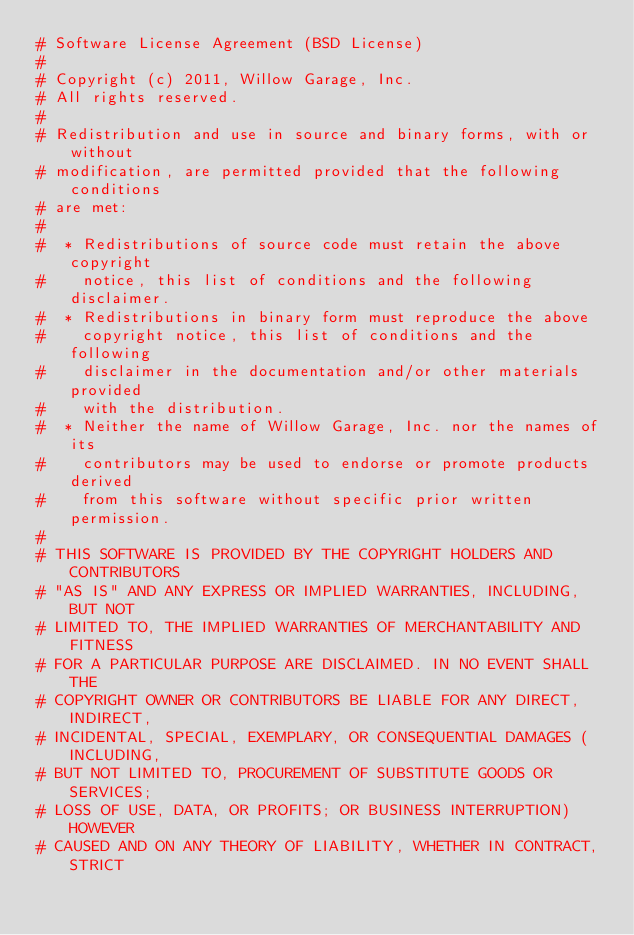<code> <loc_0><loc_0><loc_500><loc_500><_Python_># Software License Agreement (BSD License)
#
# Copyright (c) 2011, Willow Garage, Inc.
# All rights reserved.
#
# Redistribution and use in source and binary forms, with or without
# modification, are permitted provided that the following conditions
# are met:
#
#  * Redistributions of source code must retain the above copyright
#    notice, this list of conditions and the following disclaimer.
#  * Redistributions in binary form must reproduce the above
#    copyright notice, this list of conditions and the following
#    disclaimer in the documentation and/or other materials provided
#    with the distribution.
#  * Neither the name of Willow Garage, Inc. nor the names of its
#    contributors may be used to endorse or promote products derived
#    from this software without specific prior written permission.
#
# THIS SOFTWARE IS PROVIDED BY THE COPYRIGHT HOLDERS AND CONTRIBUTORS
# "AS IS" AND ANY EXPRESS OR IMPLIED WARRANTIES, INCLUDING, BUT NOT
# LIMITED TO, THE IMPLIED WARRANTIES OF MERCHANTABILITY AND FITNESS
# FOR A PARTICULAR PURPOSE ARE DISCLAIMED. IN NO EVENT SHALL THE
# COPYRIGHT OWNER OR CONTRIBUTORS BE LIABLE FOR ANY DIRECT, INDIRECT,
# INCIDENTAL, SPECIAL, EXEMPLARY, OR CONSEQUENTIAL DAMAGES (INCLUDING,
# BUT NOT LIMITED TO, PROCUREMENT OF SUBSTITUTE GOODS OR SERVICES;
# LOSS OF USE, DATA, OR PROFITS; OR BUSINESS INTERRUPTION) HOWEVER
# CAUSED AND ON ANY THEORY OF LIABILITY, WHETHER IN CONTRACT, STRICT</code> 